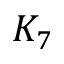Convert formula to latex. <formula><loc_0><loc_0><loc_500><loc_500>K _ { 7 }</formula> 